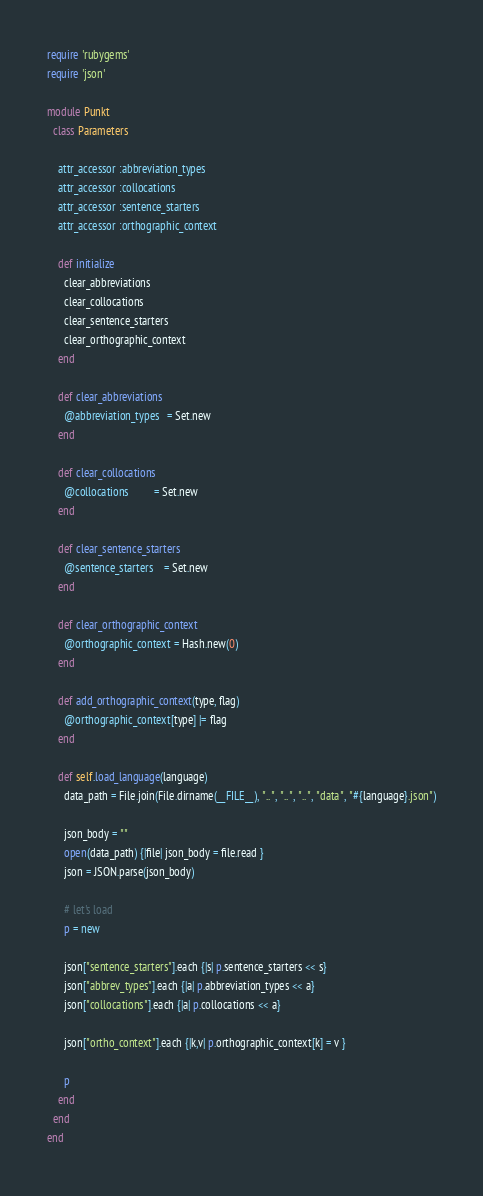Convert code to text. <code><loc_0><loc_0><loc_500><loc_500><_Ruby_>require 'rubygems'
require 'json'

module Punkt
  class Parameters
    
    attr_accessor :abbreviation_types
    attr_accessor :collocations
    attr_accessor :sentence_starters
    attr_accessor :orthographic_context
    
    def initialize
      clear_abbreviations
      clear_collocations
      clear_sentence_starters
      clear_orthographic_context
    end
    
    def clear_abbreviations
      @abbreviation_types   = Set.new
    end
    
    def clear_collocations
      @collocations         = Set.new
    end
    
    def clear_sentence_starters
      @sentence_starters    = Set.new
    end
    
    def clear_orthographic_context
      @orthographic_context = Hash.new(0)
    end
    
    def add_orthographic_context(type, flag)
      @orthographic_context[type] |= flag
    end

    def self.load_language(language)
      data_path = File.join(File.dirname(__FILE__), "..", "..", "..", "data", "#{language}.json")

      json_body = ""
      open(data_path) {|file| json_body = file.read }
      json = JSON.parse(json_body)

      # let's load
      p = new

      json["sentence_starters"].each {|s| p.sentence_starters << s}
      json["abbrev_types"].each {|a| p.abbreviation_types << a}
      json["collocations"].each {|a| p.collocations << a}

      json["ortho_context"].each {|k,v| p.orthographic_context[k] = v }

      p
    end
  end
end
</code> 